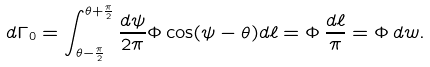<formula> <loc_0><loc_0><loc_500><loc_500>d \Gamma _ { 0 } = \int _ { \theta - \frac { \pi } { 2 } } ^ { \theta + \frac { \pi } { 2 } } \frac { d \psi } { 2 \pi } \Phi \cos ( \psi - \theta ) d \ell = \Phi \, \frac { d \ell } { \pi } = \Phi \, d w .</formula> 